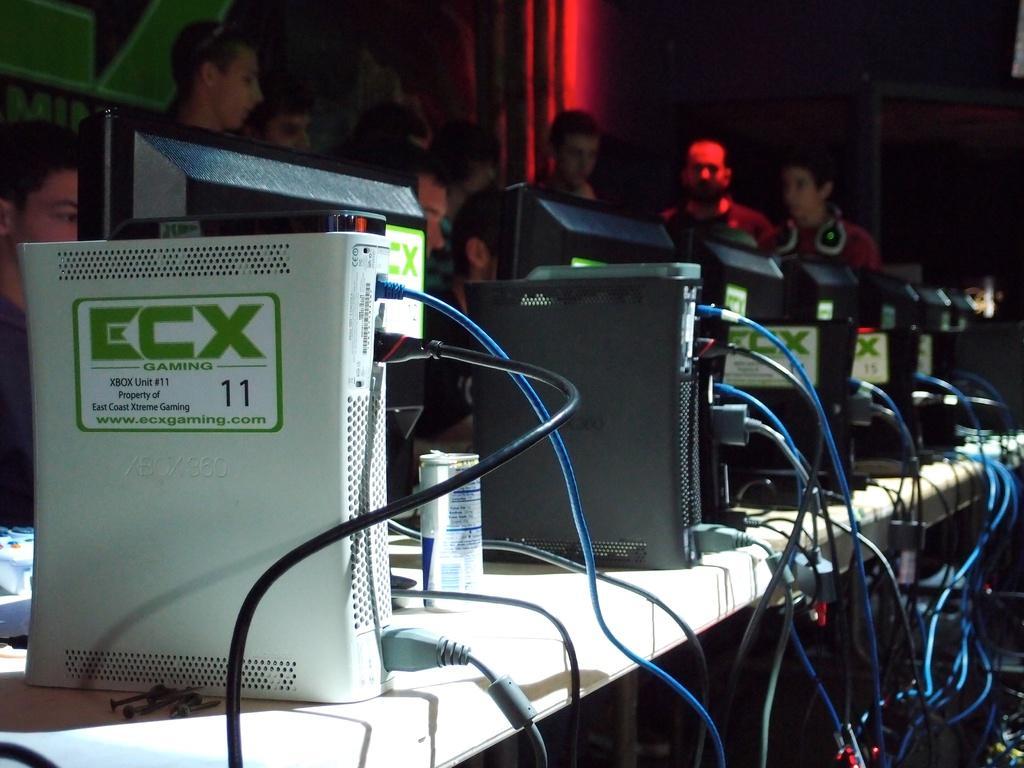In one or two sentences, can you explain what this image depicts? This is an image clicked in the dark. Here I can see few electronic devices, monitors and wires are placed on a table and also I can see a cock-tin. In the background there are few people in the dark and also I can see the wall. 